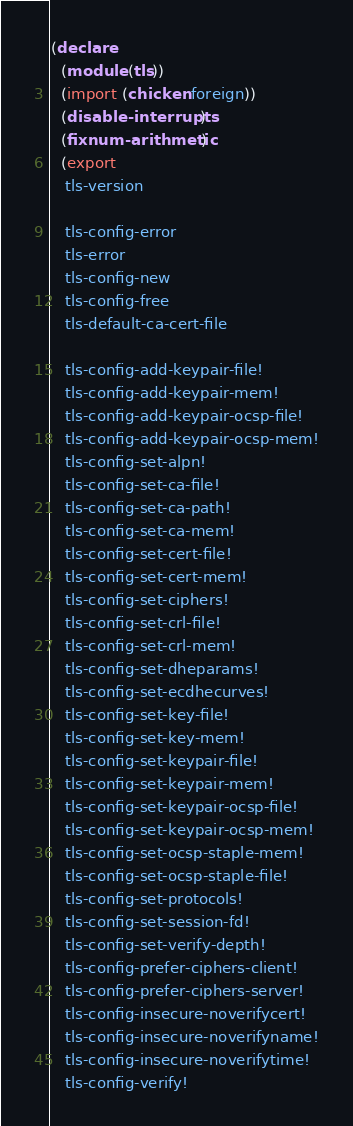<code> <loc_0><loc_0><loc_500><loc_500><_Scheme_>(declare
  (module (tls))
  (import (chicken foreign))
  (disable-interrupts)
  (fixnum-arithmetic)
  (export
   tls-version

   tls-config-error
   tls-error
   tls-config-new
   tls-config-free
   tls-default-ca-cert-file

   tls-config-add-keypair-file!
   tls-config-add-keypair-mem!
   tls-config-add-keypair-ocsp-file!
   tls-config-add-keypair-ocsp-mem!
   tls-config-set-alpn!
   tls-config-set-ca-file!
   tls-config-set-ca-path!
   tls-config-set-ca-mem!
   tls-config-set-cert-file!
   tls-config-set-cert-mem!
   tls-config-set-ciphers!
   tls-config-set-crl-file!
   tls-config-set-crl-mem!
   tls-config-set-dheparams!
   tls-config-set-ecdhecurves!
   tls-config-set-key-file!
   tls-config-set-key-mem!
   tls-config-set-keypair-file!
   tls-config-set-keypair-mem!
   tls-config-set-keypair-ocsp-file!
   tls-config-set-keypair-ocsp-mem!
   tls-config-set-ocsp-staple-mem!
   tls-config-set-ocsp-staple-file!
   tls-config-set-protocols!
   tls-config-set-session-fd!
   tls-config-set-verify-depth!
   tls-config-prefer-ciphers-client!
   tls-config-prefer-ciphers-server!
   tls-config-insecure-noverifycert!
   tls-config-insecure-noverifyname!
   tls-config-insecure-noverifytime!
   tls-config-verify!</code> 